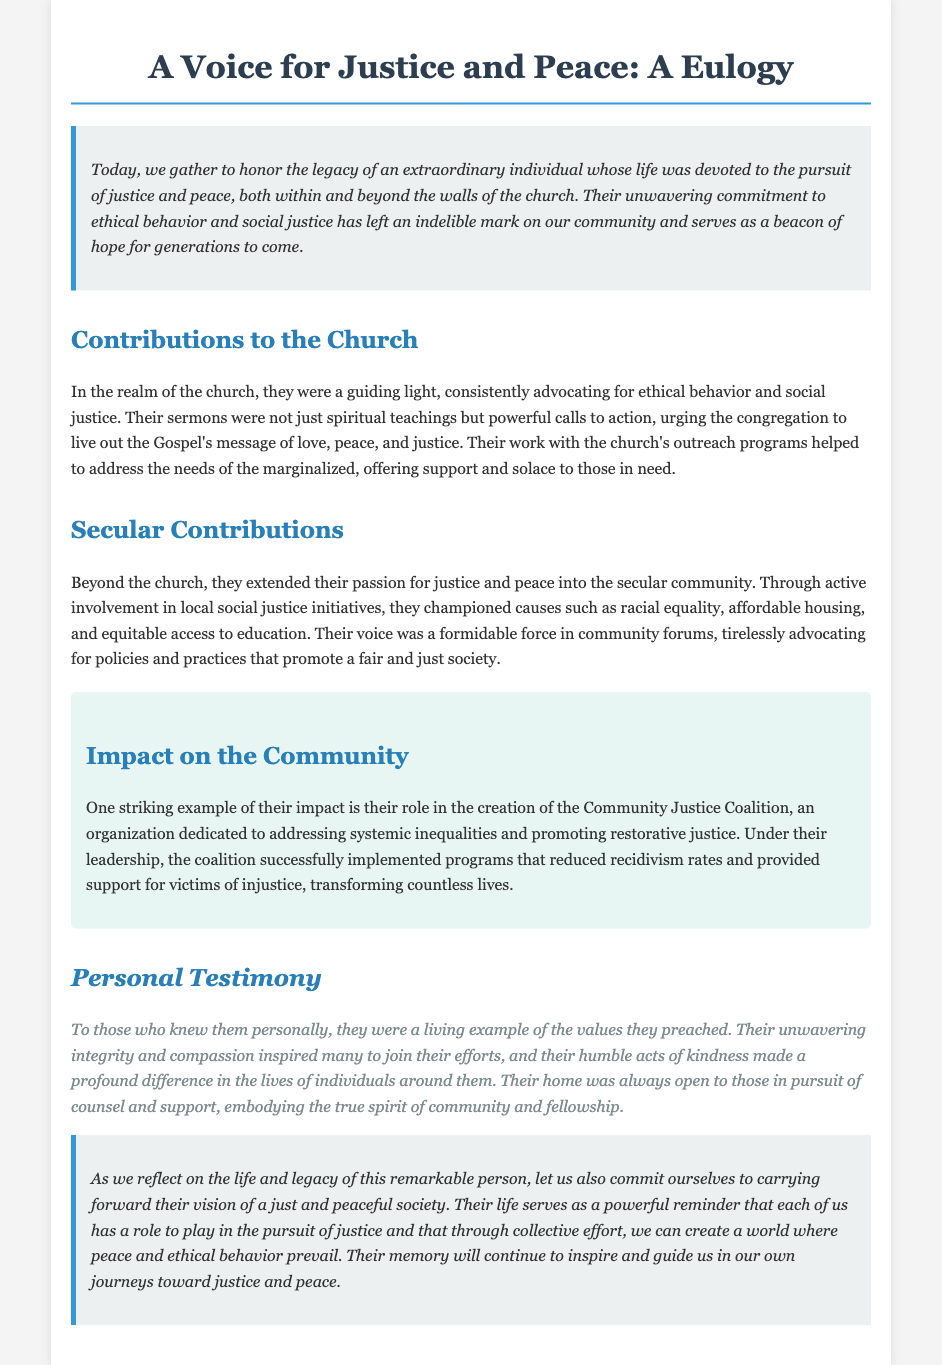What was the individual's main commitment? The individual's main commitment was the pursuit of justice and peace.
Answer: Justice and peace What coalition did the individual help create? The individual played a role in the creation of the Community Justice Coalition.
Answer: Community Justice Coalition What type of community issues did they advocate for? They advocated for issues such as racial equality, affordable housing, and equitable access to education.
Answer: Racial equality, affordable housing, and equitable access to education How did they contribute to outreach programs? Their work with outreach programs addressed the needs of the marginalized.
Answer: Addressed the needs of the marginalized What did their sermons urge the congregation to do? Their sermons urged the congregation to live out the Gospel's message of love, peace, and justice.
Answer: Live out the Gospel's message of love, peace, and justice 